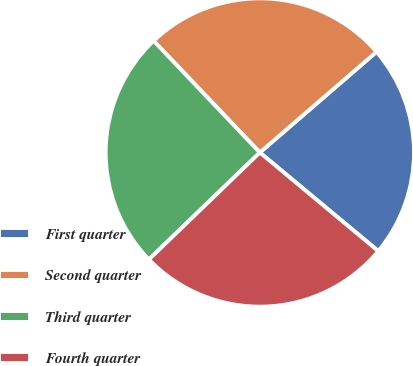Convert chart. <chart><loc_0><loc_0><loc_500><loc_500><pie_chart><fcel>First quarter<fcel>Second quarter<fcel>Third quarter<fcel>Fourth quarter<nl><fcel>22.38%<fcel>25.77%<fcel>25.11%<fcel>26.74%<nl></chart> 